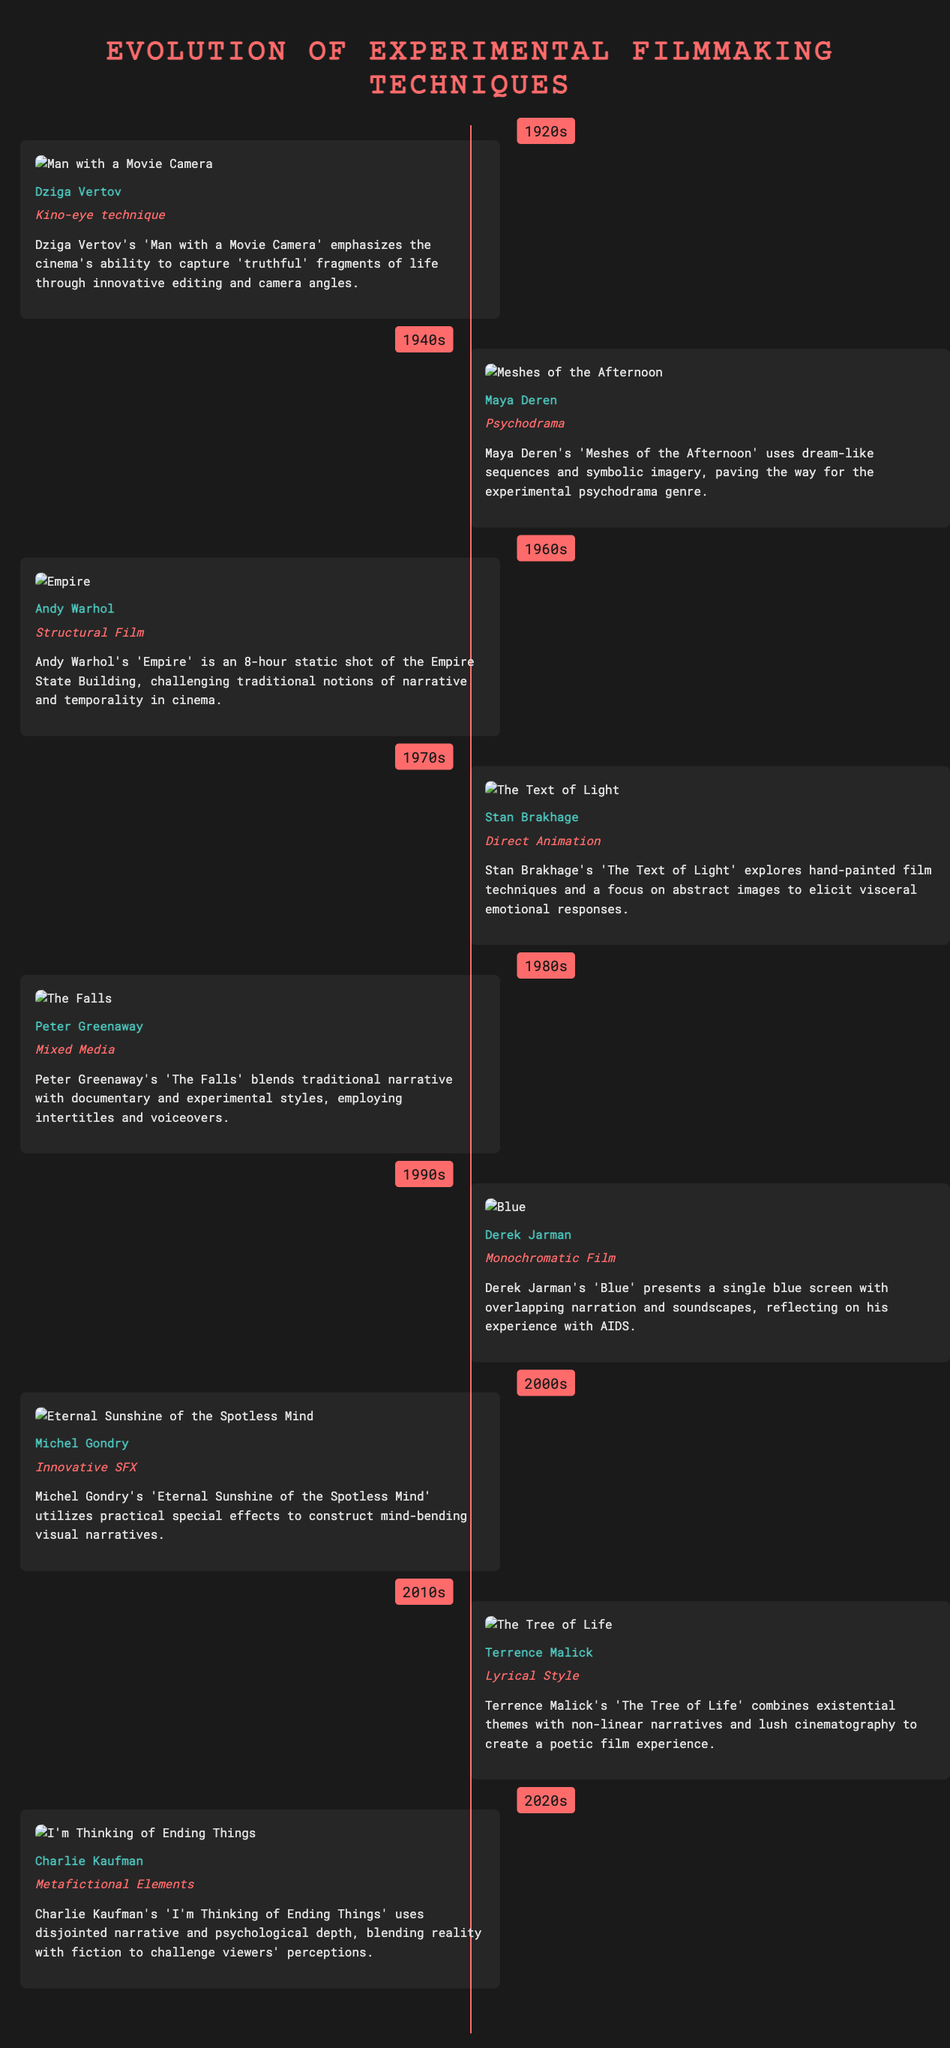What innovative technique did Dziga Vertov use? Dziga Vertov utilized the Kino-eye technique in his work.
Answer: Kino-eye technique Which film features a dream-like sequence by Maya Deren? The film 'Meshes of the Afternoon' by Maya Deren is known for its dream-like sequences.
Answer: Meshes of the Afternoon What decade did Andy Warhol release 'Empire'? 'Empire' by Andy Warhol was released in the 1960s.
Answer: 1960s Which filmmaker is associated with direct animation in the 1970s? Stan Brakhage is noted for his direct animation techniques during the 1970s.
Answer: Stan Brakhage How long is Andy Warhol's 'Empire'? 'Empire' has a runtime of eight hours, featuring a static shot.
Answer: 8 hours What style did Peter Greenaway combine in 'The Falls'? Peter Greenaway blended traditional narrative with experimental styles in 'The Falls'.
Answer: Mixed Media What year did Derek Jarman create 'Blue'? Derek Jarman created 'Blue' in the 1990s.
Answer: 1990s Which film by Michel Gondry utilizes practical special effects? Michel Gondry's 'Eternal Sunshine of the Spotless Mind' is known for its practical special effects.
Answer: Eternal Sunshine of the Spotless Mind What is a defining feature of Charlie Kaufman's work in the 2020s? Charlie Kaufman's 'I'm Thinking of Ending Things' features metafictional elements that challenge viewer perceptions.
Answer: Metafictional Elements 